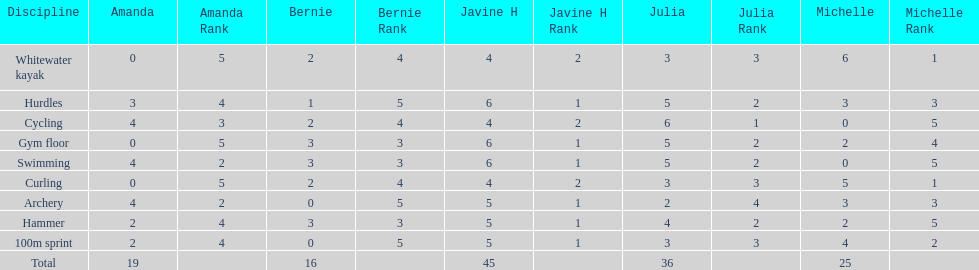Who earned the most total points? Javine H. 